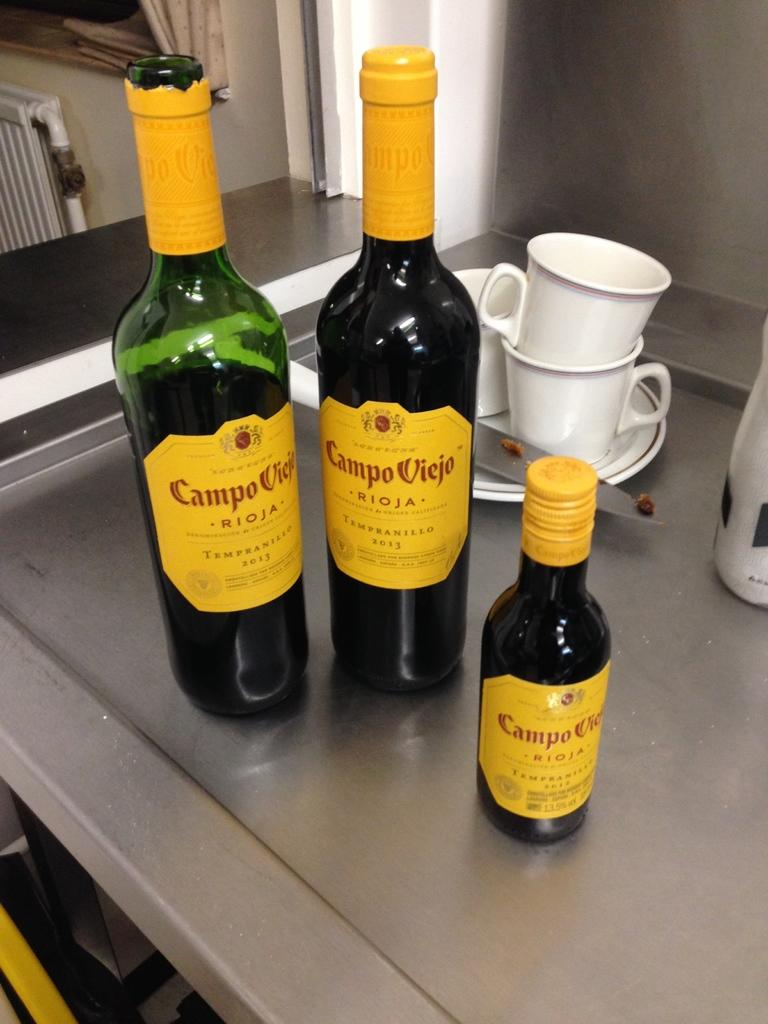Provide a one-sentence caption for the provided image. Three bottles of Campo Viejo roja sit on a metal counter. 